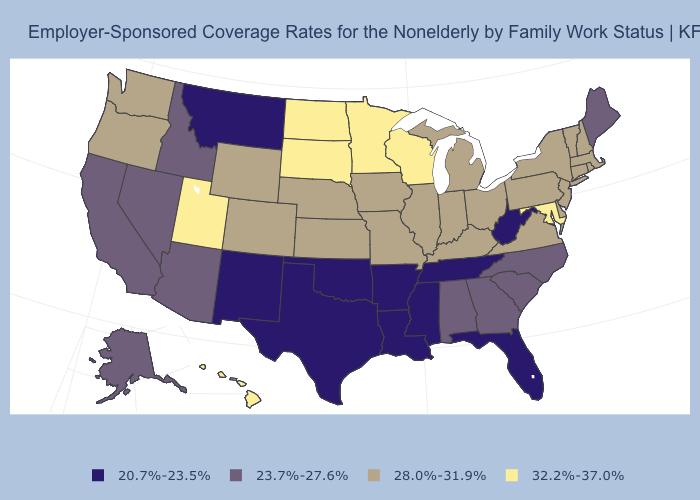Name the states that have a value in the range 20.7%-23.5%?
Short answer required. Arkansas, Florida, Louisiana, Mississippi, Montana, New Mexico, Oklahoma, Tennessee, Texas, West Virginia. Which states have the lowest value in the USA?
Concise answer only. Arkansas, Florida, Louisiana, Mississippi, Montana, New Mexico, Oklahoma, Tennessee, Texas, West Virginia. What is the value of Florida?
Short answer required. 20.7%-23.5%. Name the states that have a value in the range 20.7%-23.5%?
Write a very short answer. Arkansas, Florida, Louisiana, Mississippi, Montana, New Mexico, Oklahoma, Tennessee, Texas, West Virginia. Is the legend a continuous bar?
Concise answer only. No. Does Minnesota have a lower value than Iowa?
Quick response, please. No. What is the value of Kansas?
Concise answer only. 28.0%-31.9%. What is the value of Wyoming?
Write a very short answer. 28.0%-31.9%. What is the lowest value in states that border Colorado?
Answer briefly. 20.7%-23.5%. Name the states that have a value in the range 32.2%-37.0%?
Write a very short answer. Hawaii, Maryland, Minnesota, North Dakota, South Dakota, Utah, Wisconsin. Does Tennessee have the lowest value in the USA?
Give a very brief answer. Yes. Does Nebraska have a lower value than Idaho?
Quick response, please. No. Does Florida have the lowest value in the USA?
Be succinct. Yes. What is the lowest value in the USA?
Write a very short answer. 20.7%-23.5%. What is the lowest value in states that border Wyoming?
Keep it brief. 20.7%-23.5%. 